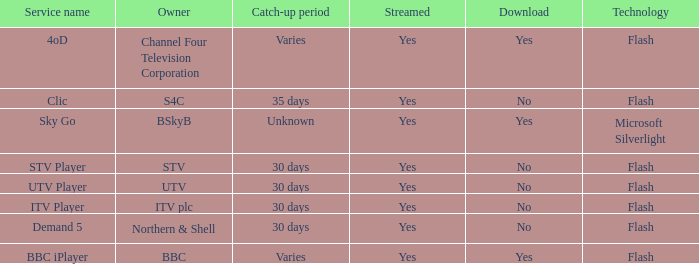What is the Service name of BBC? BBC iPlayer. 